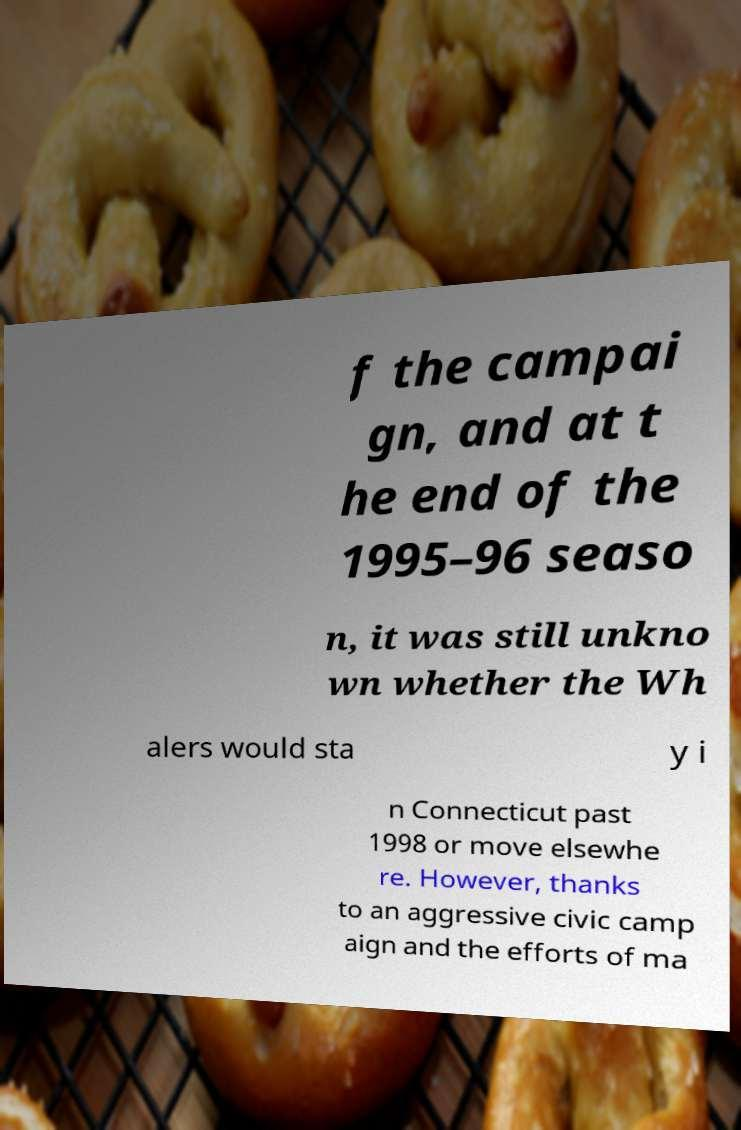I need the written content from this picture converted into text. Can you do that? f the campai gn, and at t he end of the 1995–96 seaso n, it was still unkno wn whether the Wh alers would sta y i n Connecticut past 1998 or move elsewhe re. However, thanks to an aggressive civic camp aign and the efforts of ma 